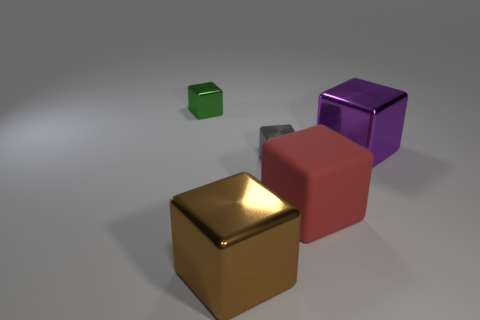What is the size of the gray shiny object that is the same shape as the big purple metallic thing?
Your answer should be compact. Small. There is a small thing in front of the green thing; is its shape the same as the large red thing?
Your response must be concise. Yes. Is there a green cube made of the same material as the tiny green object?
Provide a succinct answer. No. What is the size of the gray block?
Your answer should be compact. Small. How many cyan things are metallic blocks or blocks?
Keep it short and to the point. 0. What number of large brown metal objects are the same shape as the tiny green thing?
Make the answer very short. 1. What number of green things have the same size as the brown metallic cube?
Ensure brevity in your answer.  0. There is a green object that is the same shape as the big brown metal object; what is its material?
Your answer should be compact. Metal. There is a metal thing right of the red rubber thing; what is its color?
Your answer should be compact. Purple. Are there more purple things in front of the green shiny cube than tiny green shiny blocks?
Your answer should be very brief. No. 